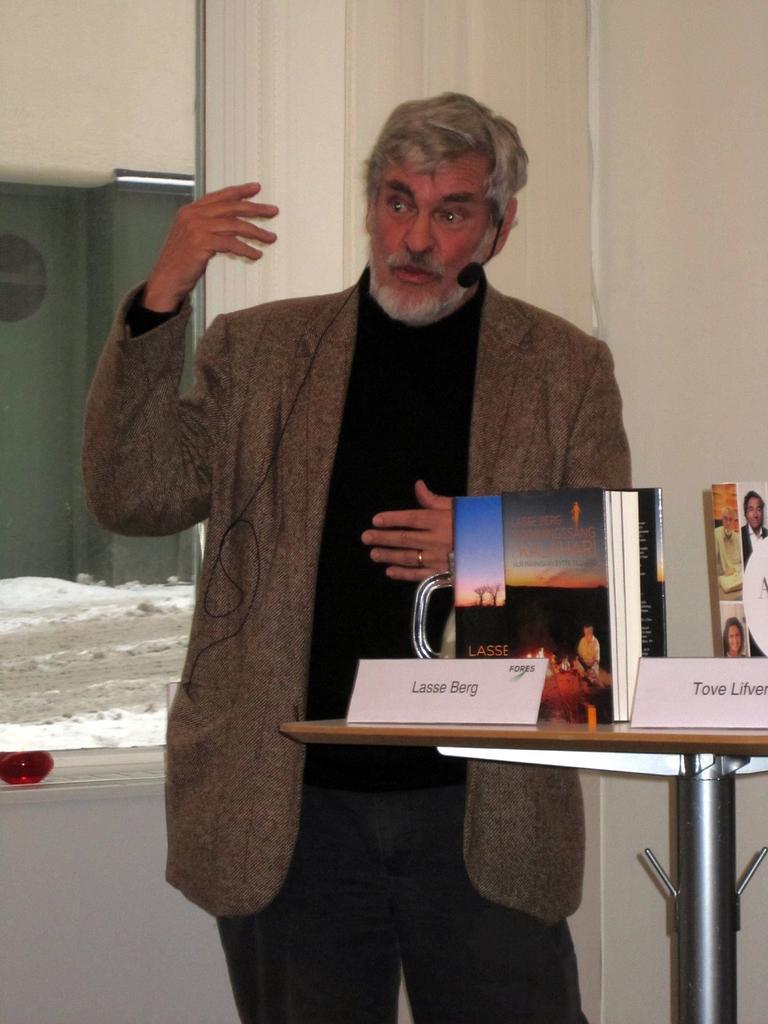Please provide a concise description of this image. In this image there is a man standing at a table. He is wearing a brown jacket and a microphone. On the table there are books and name boards. Behind him there is wall and curtain. There is also window and through it building, ground and snow can be seen. 